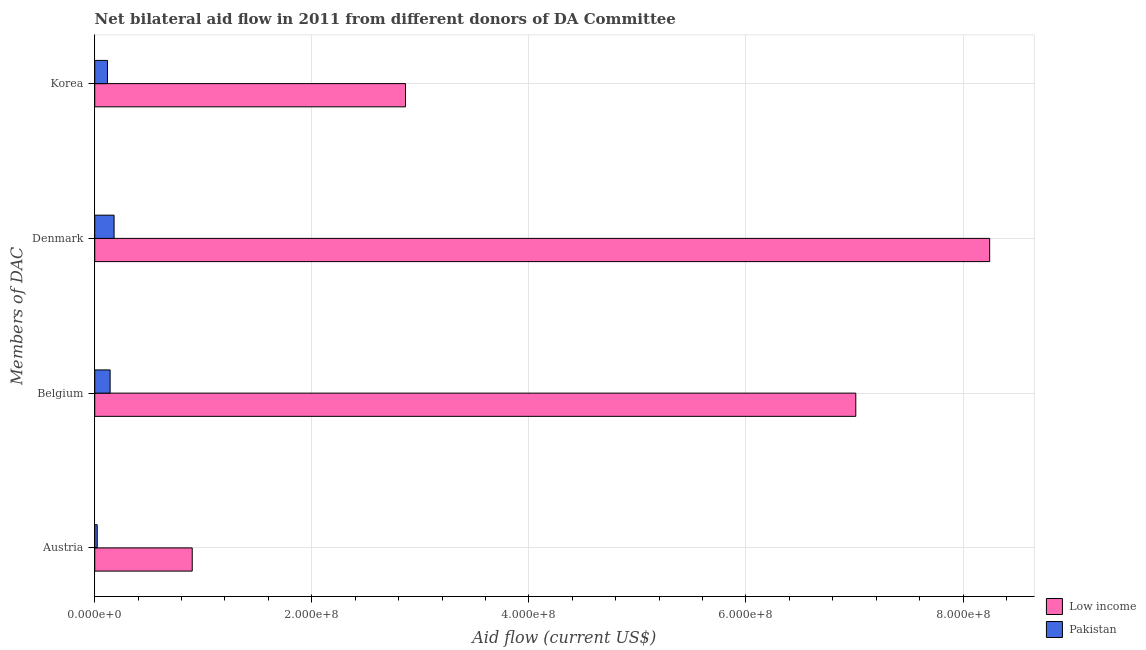Are the number of bars per tick equal to the number of legend labels?
Keep it short and to the point. Yes. How many bars are there on the 1st tick from the top?
Make the answer very short. 2. How many bars are there on the 4th tick from the bottom?
Your response must be concise. 2. What is the label of the 1st group of bars from the top?
Keep it short and to the point. Korea. What is the amount of aid given by denmark in Low income?
Keep it short and to the point. 8.24e+08. Across all countries, what is the maximum amount of aid given by belgium?
Provide a succinct answer. 7.01e+08. Across all countries, what is the minimum amount of aid given by denmark?
Ensure brevity in your answer.  1.78e+07. In which country was the amount of aid given by korea maximum?
Provide a short and direct response. Low income. In which country was the amount of aid given by denmark minimum?
Keep it short and to the point. Pakistan. What is the total amount of aid given by korea in the graph?
Keep it short and to the point. 2.98e+08. What is the difference between the amount of aid given by korea in Pakistan and that in Low income?
Keep it short and to the point. -2.75e+08. What is the difference between the amount of aid given by denmark in Pakistan and the amount of aid given by belgium in Low income?
Your response must be concise. -6.83e+08. What is the average amount of aid given by korea per country?
Make the answer very short. 1.49e+08. What is the difference between the amount of aid given by korea and amount of aid given by belgium in Low income?
Ensure brevity in your answer.  -4.15e+08. What is the ratio of the amount of aid given by korea in Pakistan to that in Low income?
Your answer should be very brief. 0.04. Is the amount of aid given by korea in Pakistan less than that in Low income?
Your answer should be very brief. Yes. Is the difference between the amount of aid given by belgium in Pakistan and Low income greater than the difference between the amount of aid given by austria in Pakistan and Low income?
Your answer should be very brief. No. What is the difference between the highest and the second highest amount of aid given by belgium?
Your response must be concise. 6.87e+08. What is the difference between the highest and the lowest amount of aid given by belgium?
Ensure brevity in your answer.  6.87e+08. In how many countries, is the amount of aid given by denmark greater than the average amount of aid given by denmark taken over all countries?
Provide a succinct answer. 1. Is it the case that in every country, the sum of the amount of aid given by austria and amount of aid given by denmark is greater than the sum of amount of aid given by belgium and amount of aid given by korea?
Provide a succinct answer. No. Is it the case that in every country, the sum of the amount of aid given by austria and amount of aid given by belgium is greater than the amount of aid given by denmark?
Your answer should be very brief. No. How many bars are there?
Provide a succinct answer. 8. Are all the bars in the graph horizontal?
Offer a very short reply. Yes. Does the graph contain any zero values?
Your answer should be very brief. No. Does the graph contain grids?
Offer a very short reply. Yes. Where does the legend appear in the graph?
Keep it short and to the point. Bottom right. How many legend labels are there?
Provide a short and direct response. 2. How are the legend labels stacked?
Your answer should be very brief. Vertical. What is the title of the graph?
Keep it short and to the point. Net bilateral aid flow in 2011 from different donors of DA Committee. What is the label or title of the X-axis?
Your response must be concise. Aid flow (current US$). What is the label or title of the Y-axis?
Offer a terse response. Members of DAC. What is the Aid flow (current US$) of Low income in Austria?
Provide a short and direct response. 8.98e+07. What is the Aid flow (current US$) in Pakistan in Austria?
Provide a short and direct response. 2.30e+06. What is the Aid flow (current US$) in Low income in Belgium?
Provide a short and direct response. 7.01e+08. What is the Aid flow (current US$) of Pakistan in Belgium?
Provide a succinct answer. 1.42e+07. What is the Aid flow (current US$) in Low income in Denmark?
Provide a short and direct response. 8.24e+08. What is the Aid flow (current US$) of Pakistan in Denmark?
Give a very brief answer. 1.78e+07. What is the Aid flow (current US$) of Low income in Korea?
Ensure brevity in your answer.  2.86e+08. What is the Aid flow (current US$) of Pakistan in Korea?
Provide a succinct answer. 1.17e+07. Across all Members of DAC, what is the maximum Aid flow (current US$) in Low income?
Keep it short and to the point. 8.24e+08. Across all Members of DAC, what is the maximum Aid flow (current US$) of Pakistan?
Provide a short and direct response. 1.78e+07. Across all Members of DAC, what is the minimum Aid flow (current US$) of Low income?
Provide a short and direct response. 8.98e+07. Across all Members of DAC, what is the minimum Aid flow (current US$) of Pakistan?
Offer a terse response. 2.30e+06. What is the total Aid flow (current US$) in Low income in the graph?
Your response must be concise. 1.90e+09. What is the total Aid flow (current US$) of Pakistan in the graph?
Provide a short and direct response. 4.60e+07. What is the difference between the Aid flow (current US$) in Low income in Austria and that in Belgium?
Ensure brevity in your answer.  -6.11e+08. What is the difference between the Aid flow (current US$) in Pakistan in Austria and that in Belgium?
Your response must be concise. -1.19e+07. What is the difference between the Aid flow (current US$) of Low income in Austria and that in Denmark?
Your answer should be very brief. -7.35e+08. What is the difference between the Aid flow (current US$) of Pakistan in Austria and that in Denmark?
Ensure brevity in your answer.  -1.55e+07. What is the difference between the Aid flow (current US$) of Low income in Austria and that in Korea?
Give a very brief answer. -1.96e+08. What is the difference between the Aid flow (current US$) in Pakistan in Austria and that in Korea?
Your answer should be compact. -9.44e+06. What is the difference between the Aid flow (current US$) of Low income in Belgium and that in Denmark?
Keep it short and to the point. -1.23e+08. What is the difference between the Aid flow (current US$) of Pakistan in Belgium and that in Denmark?
Provide a short and direct response. -3.65e+06. What is the difference between the Aid flow (current US$) of Low income in Belgium and that in Korea?
Provide a succinct answer. 4.15e+08. What is the difference between the Aid flow (current US$) in Pakistan in Belgium and that in Korea?
Your response must be concise. 2.44e+06. What is the difference between the Aid flow (current US$) of Low income in Denmark and that in Korea?
Offer a terse response. 5.38e+08. What is the difference between the Aid flow (current US$) in Pakistan in Denmark and that in Korea?
Ensure brevity in your answer.  6.09e+06. What is the difference between the Aid flow (current US$) in Low income in Austria and the Aid flow (current US$) in Pakistan in Belgium?
Give a very brief answer. 7.56e+07. What is the difference between the Aid flow (current US$) of Low income in Austria and the Aid flow (current US$) of Pakistan in Denmark?
Offer a very short reply. 7.20e+07. What is the difference between the Aid flow (current US$) in Low income in Austria and the Aid flow (current US$) in Pakistan in Korea?
Keep it short and to the point. 7.81e+07. What is the difference between the Aid flow (current US$) in Low income in Belgium and the Aid flow (current US$) in Pakistan in Denmark?
Provide a succinct answer. 6.83e+08. What is the difference between the Aid flow (current US$) in Low income in Belgium and the Aid flow (current US$) in Pakistan in Korea?
Offer a terse response. 6.89e+08. What is the difference between the Aid flow (current US$) of Low income in Denmark and the Aid flow (current US$) of Pakistan in Korea?
Your answer should be compact. 8.13e+08. What is the average Aid flow (current US$) of Low income per Members of DAC?
Keep it short and to the point. 4.75e+08. What is the average Aid flow (current US$) of Pakistan per Members of DAC?
Keep it short and to the point. 1.15e+07. What is the difference between the Aid flow (current US$) of Low income and Aid flow (current US$) of Pakistan in Austria?
Provide a short and direct response. 8.75e+07. What is the difference between the Aid flow (current US$) in Low income and Aid flow (current US$) in Pakistan in Belgium?
Give a very brief answer. 6.87e+08. What is the difference between the Aid flow (current US$) in Low income and Aid flow (current US$) in Pakistan in Denmark?
Keep it short and to the point. 8.07e+08. What is the difference between the Aid flow (current US$) of Low income and Aid flow (current US$) of Pakistan in Korea?
Your answer should be very brief. 2.75e+08. What is the ratio of the Aid flow (current US$) of Low income in Austria to that in Belgium?
Keep it short and to the point. 0.13. What is the ratio of the Aid flow (current US$) in Pakistan in Austria to that in Belgium?
Ensure brevity in your answer.  0.16. What is the ratio of the Aid flow (current US$) in Low income in Austria to that in Denmark?
Make the answer very short. 0.11. What is the ratio of the Aid flow (current US$) of Pakistan in Austria to that in Denmark?
Give a very brief answer. 0.13. What is the ratio of the Aid flow (current US$) in Low income in Austria to that in Korea?
Provide a succinct answer. 0.31. What is the ratio of the Aid flow (current US$) of Pakistan in Austria to that in Korea?
Your answer should be very brief. 0.2. What is the ratio of the Aid flow (current US$) of Low income in Belgium to that in Denmark?
Offer a terse response. 0.85. What is the ratio of the Aid flow (current US$) in Pakistan in Belgium to that in Denmark?
Your response must be concise. 0.8. What is the ratio of the Aid flow (current US$) of Low income in Belgium to that in Korea?
Keep it short and to the point. 2.45. What is the ratio of the Aid flow (current US$) of Pakistan in Belgium to that in Korea?
Give a very brief answer. 1.21. What is the ratio of the Aid flow (current US$) in Low income in Denmark to that in Korea?
Your answer should be very brief. 2.88. What is the ratio of the Aid flow (current US$) in Pakistan in Denmark to that in Korea?
Ensure brevity in your answer.  1.52. What is the difference between the highest and the second highest Aid flow (current US$) in Low income?
Give a very brief answer. 1.23e+08. What is the difference between the highest and the second highest Aid flow (current US$) of Pakistan?
Provide a short and direct response. 3.65e+06. What is the difference between the highest and the lowest Aid flow (current US$) in Low income?
Offer a very short reply. 7.35e+08. What is the difference between the highest and the lowest Aid flow (current US$) in Pakistan?
Give a very brief answer. 1.55e+07. 